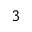<formula> <loc_0><loc_0><loc_500><loc_500>_ { 3 }</formula> 